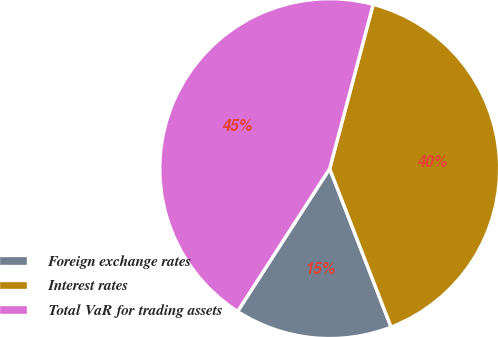Convert chart. <chart><loc_0><loc_0><loc_500><loc_500><pie_chart><fcel>Foreign exchange rates<fcel>Interest rates<fcel>Total VaR for trading assets<nl><fcel>15.0%<fcel>40.0%<fcel>45.0%<nl></chart> 